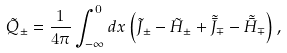<formula> <loc_0><loc_0><loc_500><loc_500>\tilde { Q } _ { \pm } = { \frac { 1 } { 4 \pi } } \int _ { - \infty } ^ { 0 } d x \left ( \tilde { J } _ { \pm } - \tilde { H } _ { \pm } + \tilde { \bar { J } } _ { \mp } - \tilde { \bar { H } } _ { \mp } \right ) ,</formula> 